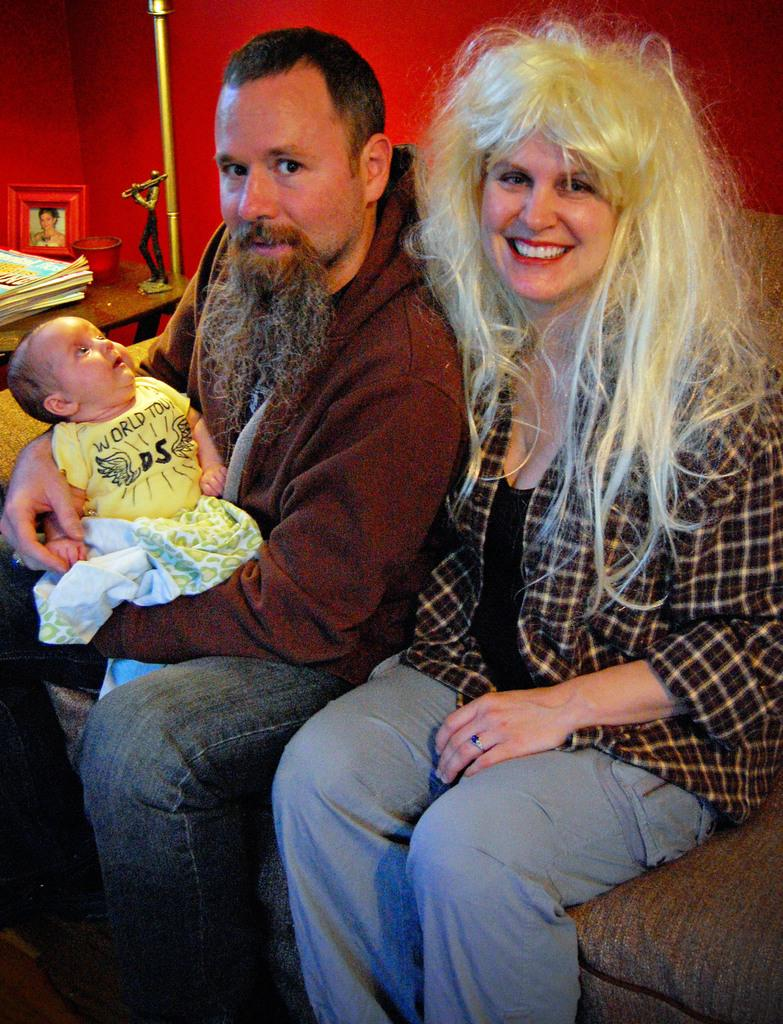What are the persons in the image doing? The persons in the image are sitting on the sofa and holding a baby. What can be seen in the background of the image? There is a table, a photo frame, books, a stand, and a wall in the background. What type of shoe is the baby wearing in the image? There is no shoe visible on the baby in the image. What kind of yam is being prepared on the stand in the background? There is no yam or any food preparation visible in the image. 